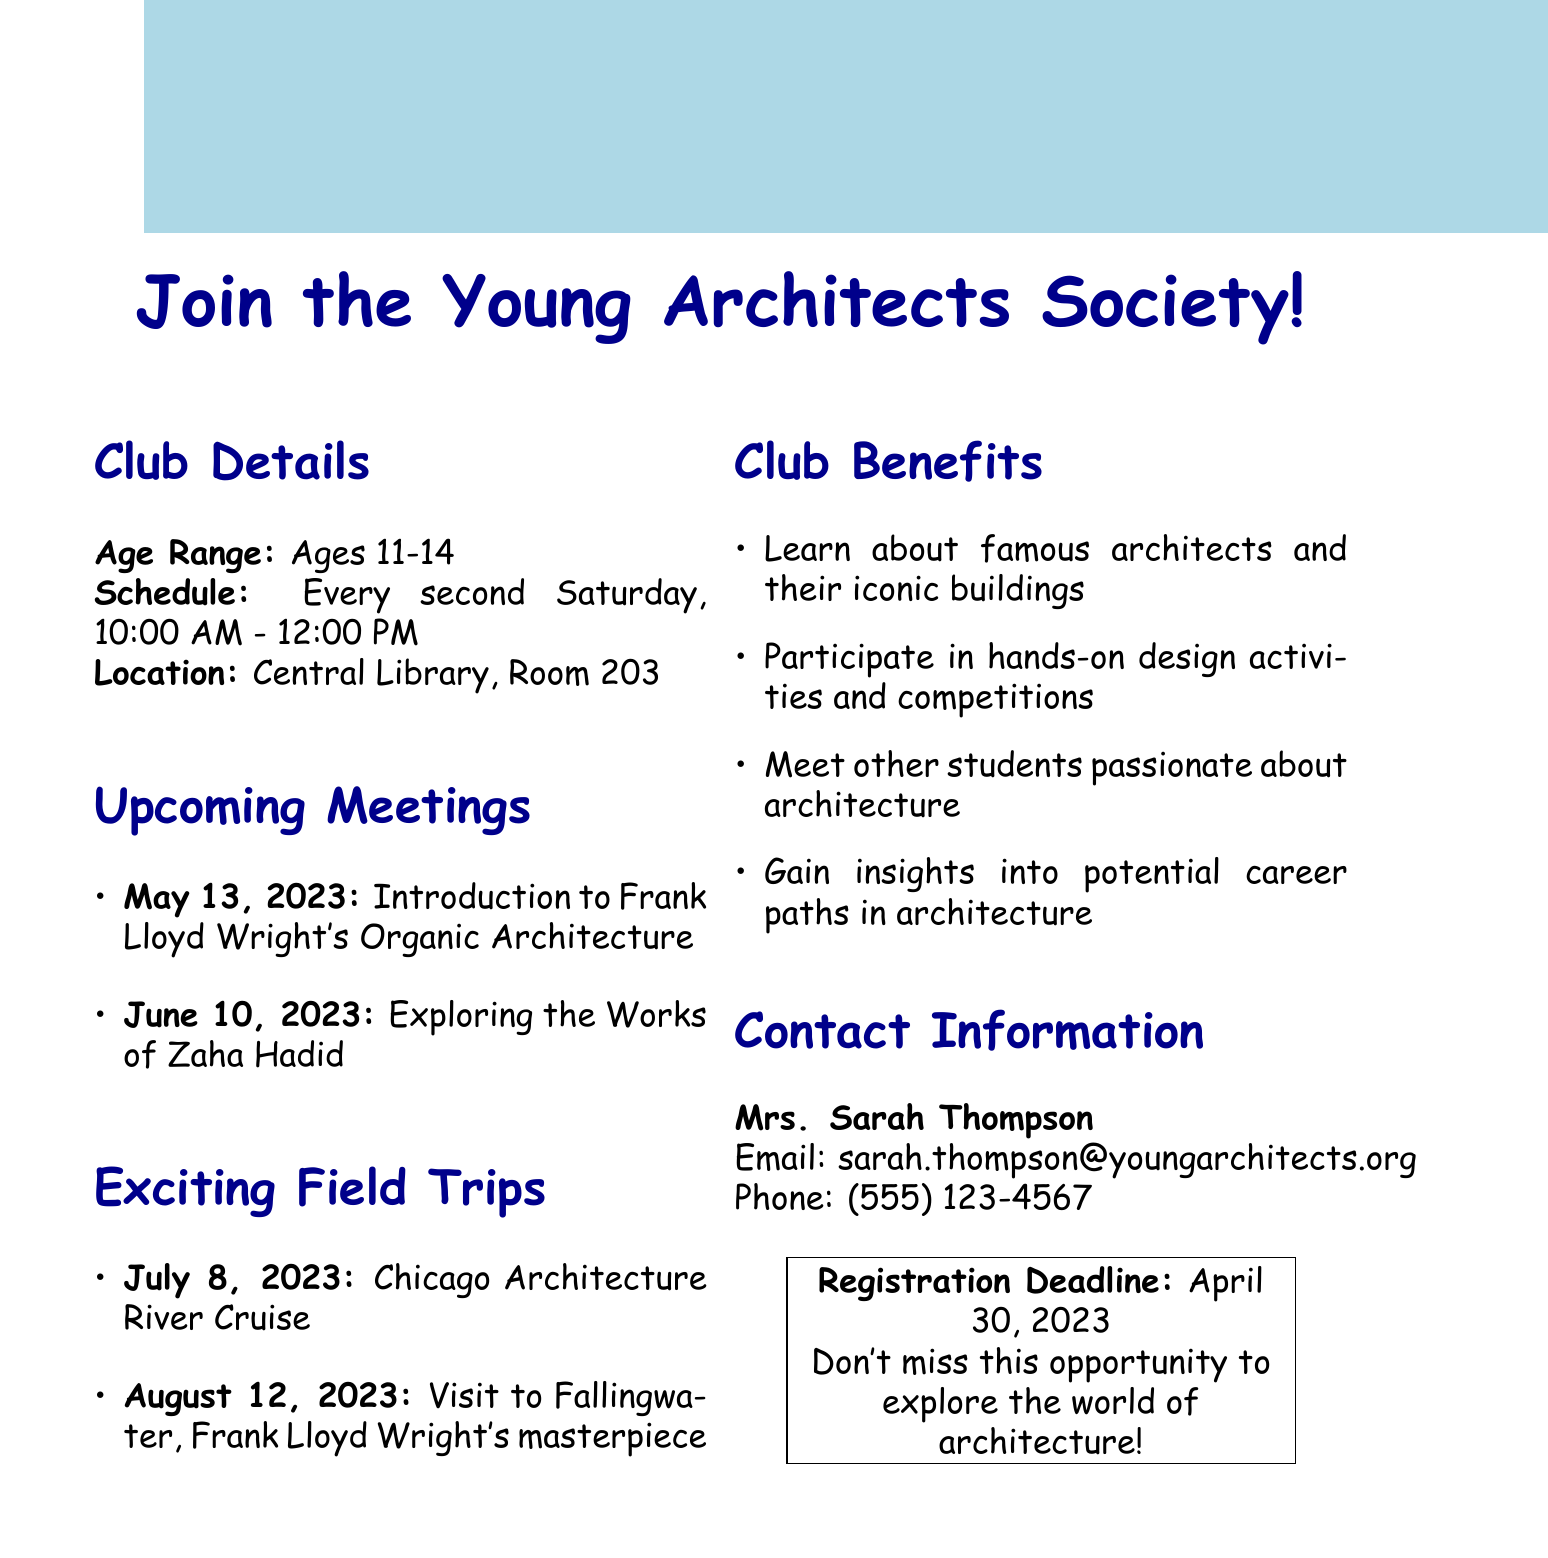What is the age range for club members? The age range specified in the document for club members is listed under club details.
Answer: Ages 11-14 When is the next meeting scheduled? The next meeting date is found in the upcoming meetings section of the document.
Answer: May 13, 2023 What topic will be discussed in the June meeting? The topic is part of the list of upcoming meetings mentioned in the document.
Answer: Exploring the Works of Zaha Hadid Where will the Chicago Architecture River Cruise take place? The destination for the field trip is noted in the exciting field trips section of the document.
Answer: Chicago Who is the contact person for the club? The contact person is mentioned under the contact information section of the document.
Answer: Mrs. Sarah Thompson What is the registration deadline? The registration deadline is stated in the last section of the document.
Answer: April 30, 2023 How often do club meetings occur? The frequency of meetings can be found in the meeting schedule part of the document.
Answer: Every second Saturday 